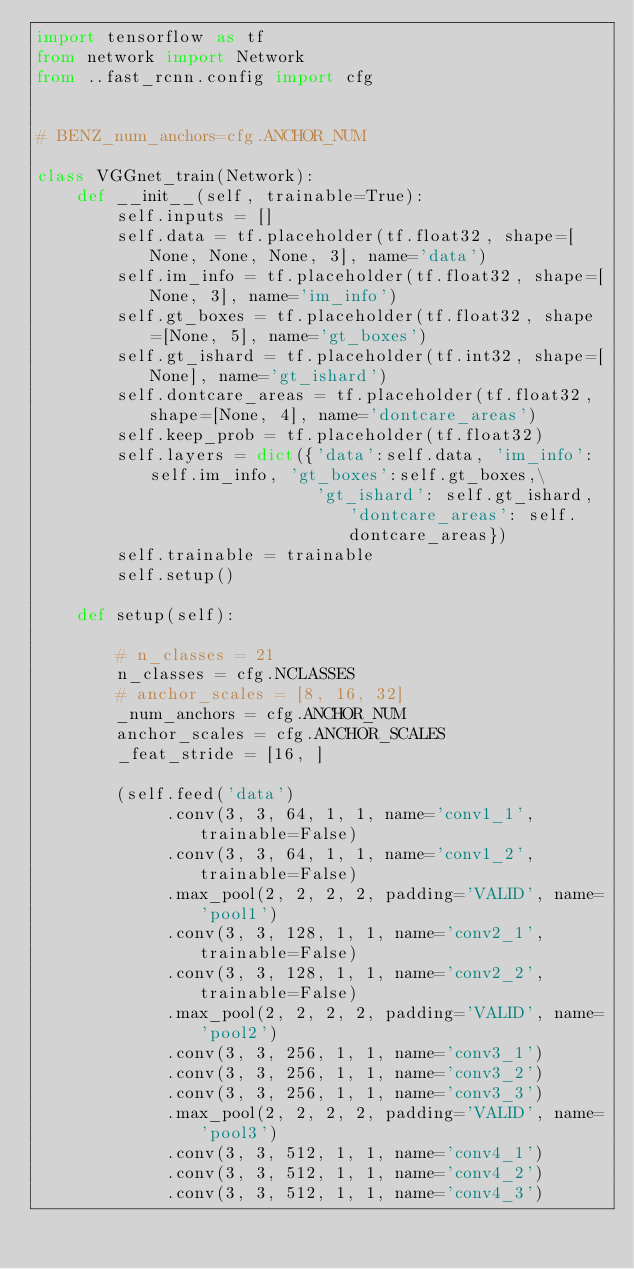<code> <loc_0><loc_0><loc_500><loc_500><_Python_>import tensorflow as tf
from network import Network
from ..fast_rcnn.config import cfg


# BENZ_num_anchors=cfg.ANCHOR_NUM

class VGGnet_train(Network):
    def __init__(self, trainable=True):
        self.inputs = []
        self.data = tf.placeholder(tf.float32, shape=[None, None, None, 3], name='data')
        self.im_info = tf.placeholder(tf.float32, shape=[None, 3], name='im_info')
        self.gt_boxes = tf.placeholder(tf.float32, shape=[None, 5], name='gt_boxes')
        self.gt_ishard = tf.placeholder(tf.int32, shape=[None], name='gt_ishard')
        self.dontcare_areas = tf.placeholder(tf.float32, shape=[None, 4], name='dontcare_areas')
        self.keep_prob = tf.placeholder(tf.float32)
        self.layers = dict({'data':self.data, 'im_info':self.im_info, 'gt_boxes':self.gt_boxes,\
                            'gt_ishard': self.gt_ishard, 'dontcare_areas': self.dontcare_areas})
        self.trainable = trainable
        self.setup()

    def setup(self):

        # n_classes = 21
        n_classes = cfg.NCLASSES
        # anchor_scales = [8, 16, 32]
        _num_anchors = cfg.ANCHOR_NUM
        anchor_scales = cfg.ANCHOR_SCALES
        _feat_stride = [16, ]

        (self.feed('data')
             .conv(3, 3, 64, 1, 1, name='conv1_1', trainable=False)
             .conv(3, 3, 64, 1, 1, name='conv1_2', trainable=False)
             .max_pool(2, 2, 2, 2, padding='VALID', name='pool1')
             .conv(3, 3, 128, 1, 1, name='conv2_1', trainable=False)
             .conv(3, 3, 128, 1, 1, name='conv2_2', trainable=False)
             .max_pool(2, 2, 2, 2, padding='VALID', name='pool2')
             .conv(3, 3, 256, 1, 1, name='conv3_1')
             .conv(3, 3, 256, 1, 1, name='conv3_2')
             .conv(3, 3, 256, 1, 1, name='conv3_3')
             .max_pool(2, 2, 2, 2, padding='VALID', name='pool3')
             .conv(3, 3, 512, 1, 1, name='conv4_1')
             .conv(3, 3, 512, 1, 1, name='conv4_2')
             .conv(3, 3, 512, 1, 1, name='conv4_3')</code> 